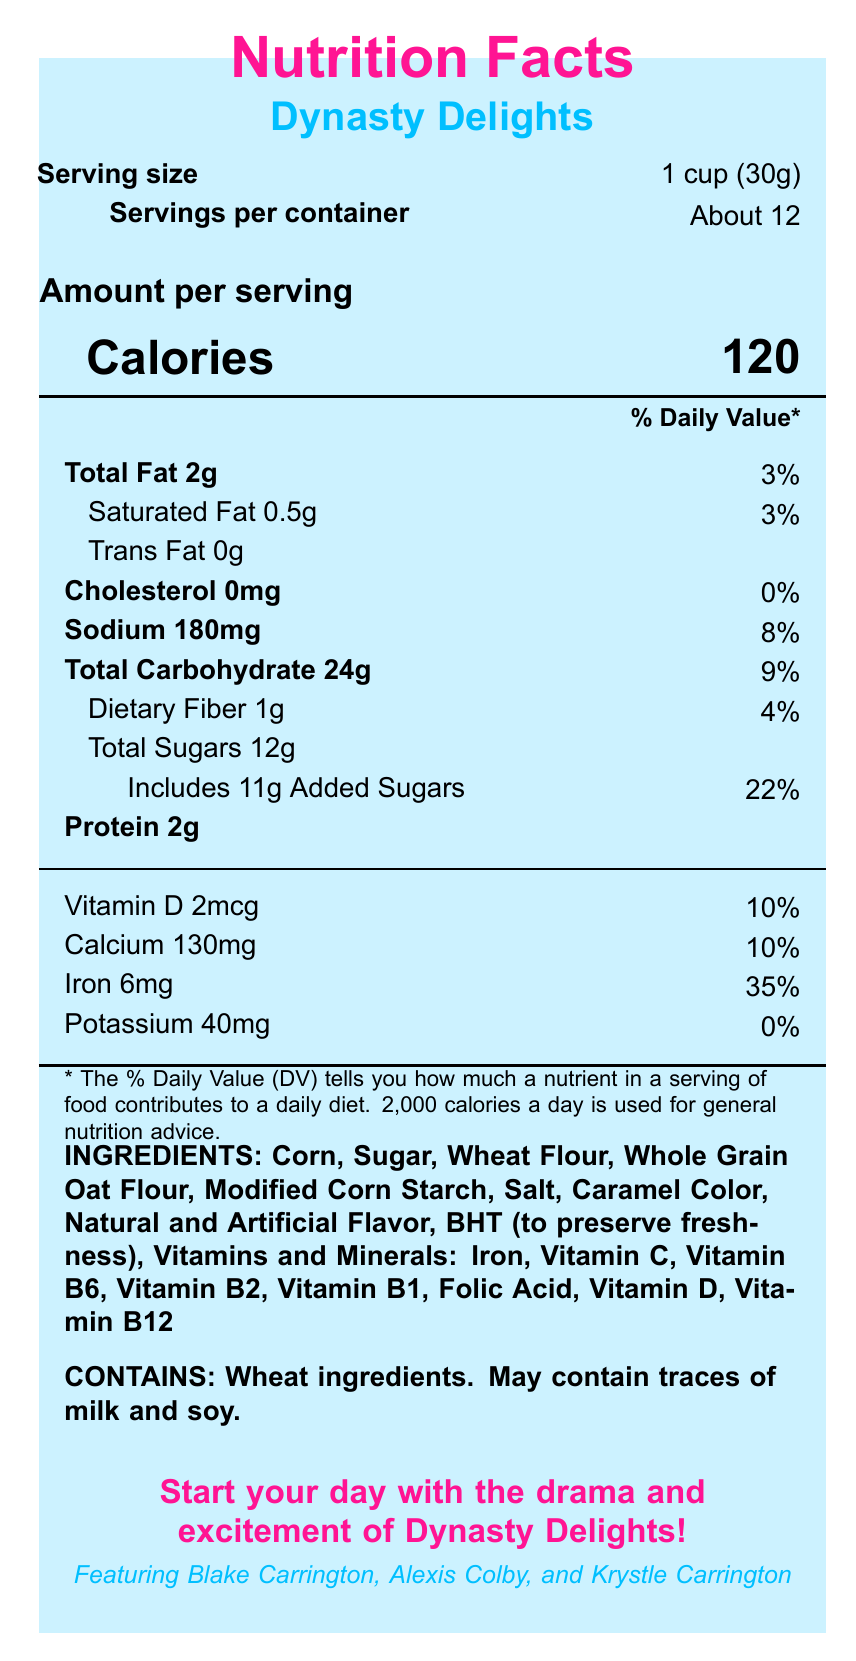what is the serving size? The serving size is mentioned under the "Serving size" section of the document.
Answer: 1 cup (30g) how many servings per container are there? The number of servings per container is listed as "About 12".
Answer: About 12 how much Total Fat is there per serving? The document states that the Total Fat per serving is 2g.
Answer: 2g how many grams of Protein are in one serving? The Protein content per serving is listed as 2g.
Answer: 2g what is the amount of Total Sugars in one serving? The Total Sugars amount is specified as 12g per serving.
Answer: 12g how much Sodium is in one serving? A. 90mg B. 180mg C. 200mg D. 150mg The Sodium content per serving is stated as 180mg.
Answer: B. 180mg what percentage of the Daily Value is Vitamin D in one serving? A. 5% B. 10% C. 15% D. 20% The percentage of the Daily Value for Vitamin D is listed as 10%.
Answer: B. 10% is there any Trans Fat in a serving of Dynasty Delights? The document specifies that there is 0g of Trans Fat per serving.
Answer: No what is the main idea of this document? The document lists the nutritional content per serving, ingredients, allergen information, a marketing slogan, and details about the soap opera characters featured.
Answer: The document provides nutrition facts and additional information for the breakfast cereal "Dynasty Delights". what is in the "80s-themed prize"? The prize information is mentioned near the bottom of the document.
Answer: Win a VHS player and a complete set of Dynasty episodes! can we determine the exact price of the cereal from this document? The document does not provide any information about the price of the cereal.
Answer: Cannot be determined who are the featured soap opera characters? The featured soap opera characters are listed as Blake Carrington, Alexis Colby, and Krystle Carrington.
Answer: Blake Carrington, Alexis Colby, and Krystle Carrington does the cereal contain added sugars? The document indicates that the cereal includes 11g of Added Sugars.
Answer: Yes what percentage of the Daily Value is Iron in one serving? The percentage of the Daily Value for Iron is listed as 35%.
Answer: 35% name two vitamins or minerals included in the cereal ingredients. Among the ingredients, the vitamins listed include Iron, Vitamin C, Vitamin B6, Vitamin B2, Vitamin B1, Folic Acid, Vitamin D, Vitamin B12.
Answer: Vitamin C, Vitamin B6 